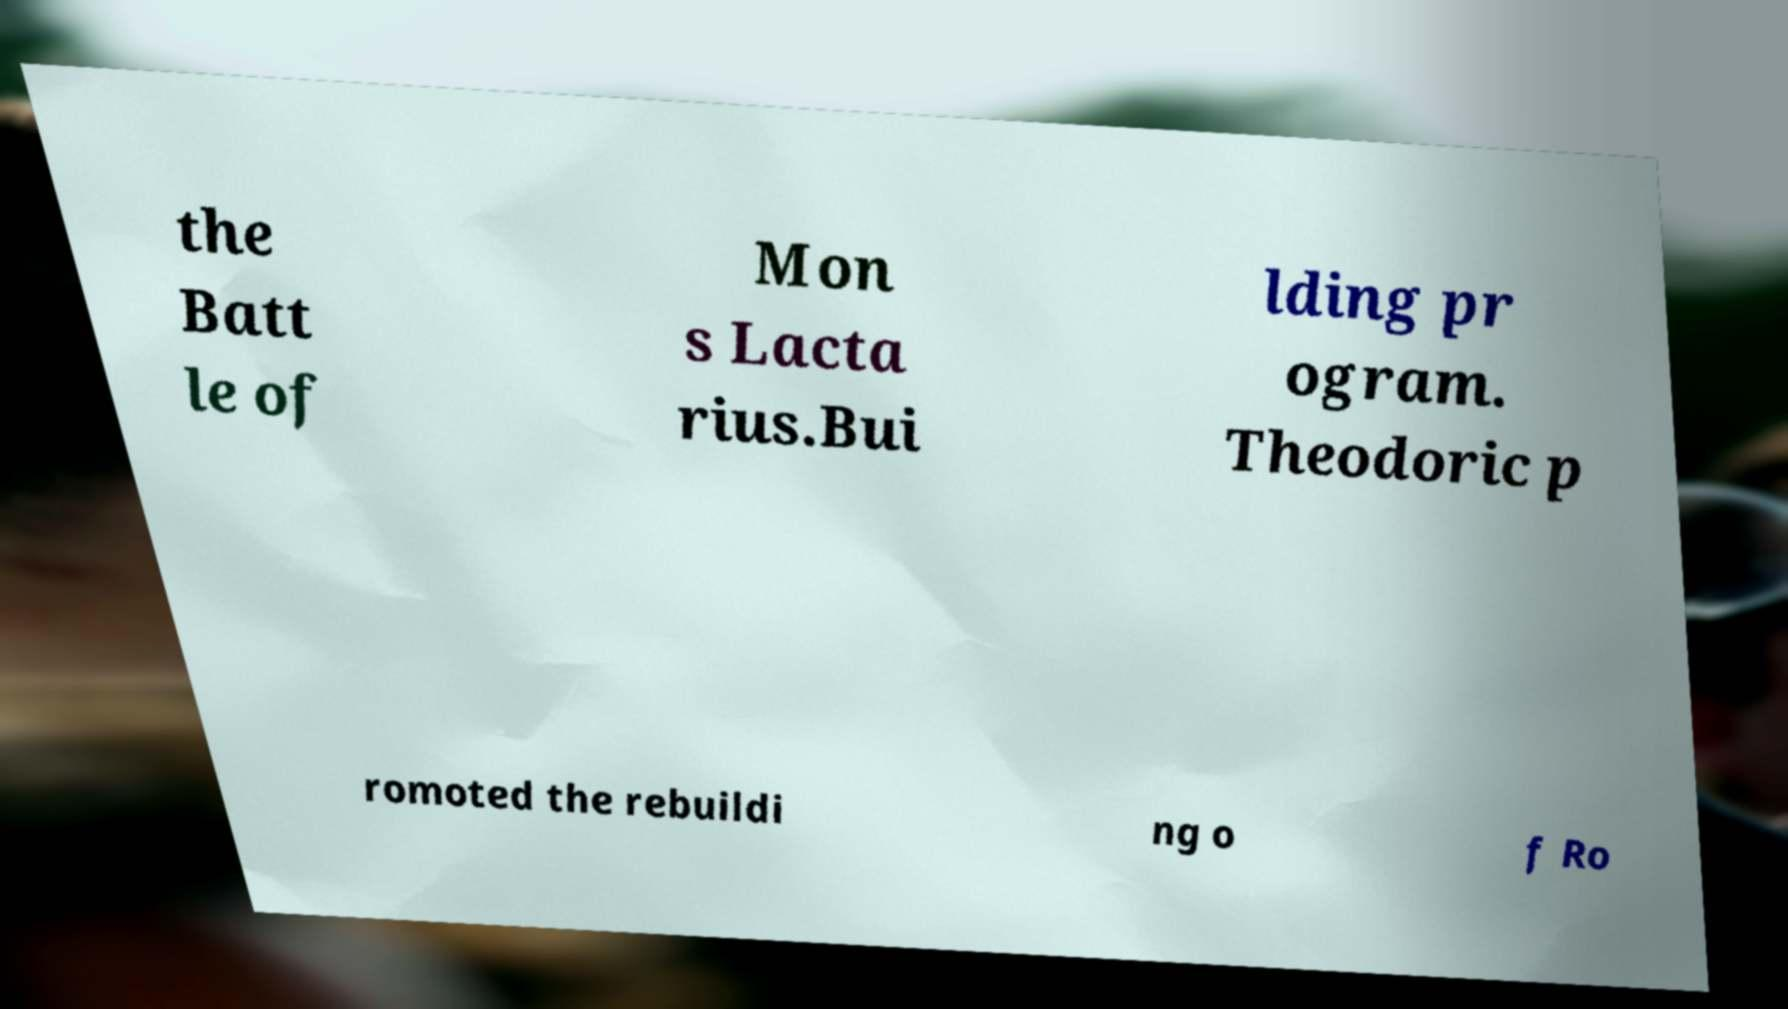Could you extract and type out the text from this image? the Batt le of Mon s Lacta rius.Bui lding pr ogram. Theodoric p romoted the rebuildi ng o f Ro 